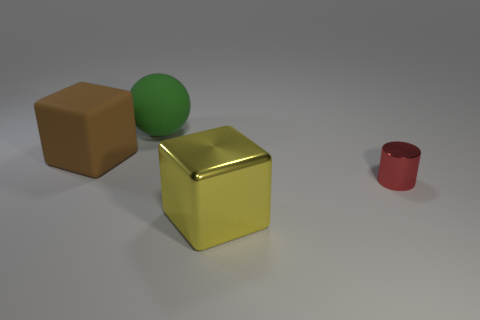Is there anything else that has the same size as the red cylinder?
Keep it short and to the point. No. Is there any other thing that has the same shape as the green matte thing?
Your response must be concise. No. There is a small shiny object; is its shape the same as the metal thing that is to the left of the tiny red cylinder?
Your answer should be compact. No. The large cube that is the same material as the red object is what color?
Ensure brevity in your answer.  Yellow. The metallic block is what color?
Your answer should be compact. Yellow. Do the small object and the large thing that is in front of the red metal cylinder have the same material?
Your answer should be very brief. Yes. What number of big things are in front of the large green matte object and behind the brown rubber cube?
Ensure brevity in your answer.  0. There is a matte thing that is the same size as the brown cube; what is its shape?
Offer a terse response. Sphere. There is a metal thing to the right of the big thing that is right of the big rubber ball; are there any big yellow blocks that are behind it?
Your answer should be compact. No. Do the large shiny block and the big rubber object in front of the large sphere have the same color?
Make the answer very short. No. 